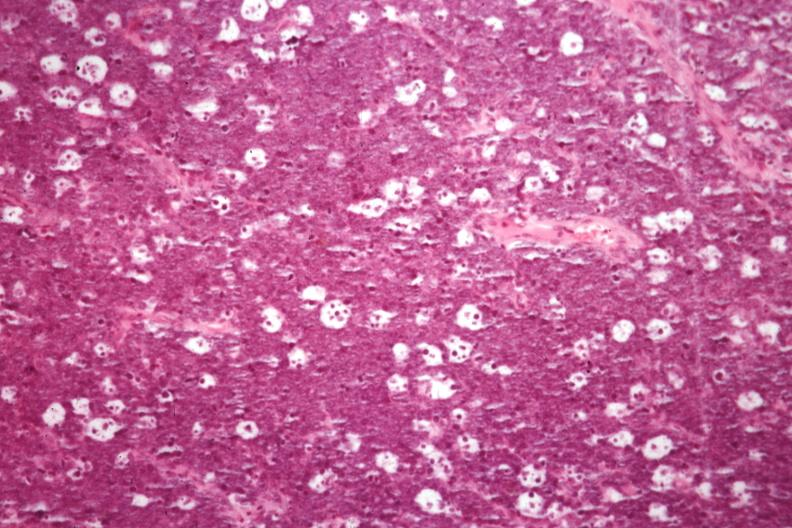what is present?
Answer the question using a single word or phrase. Lymph node 